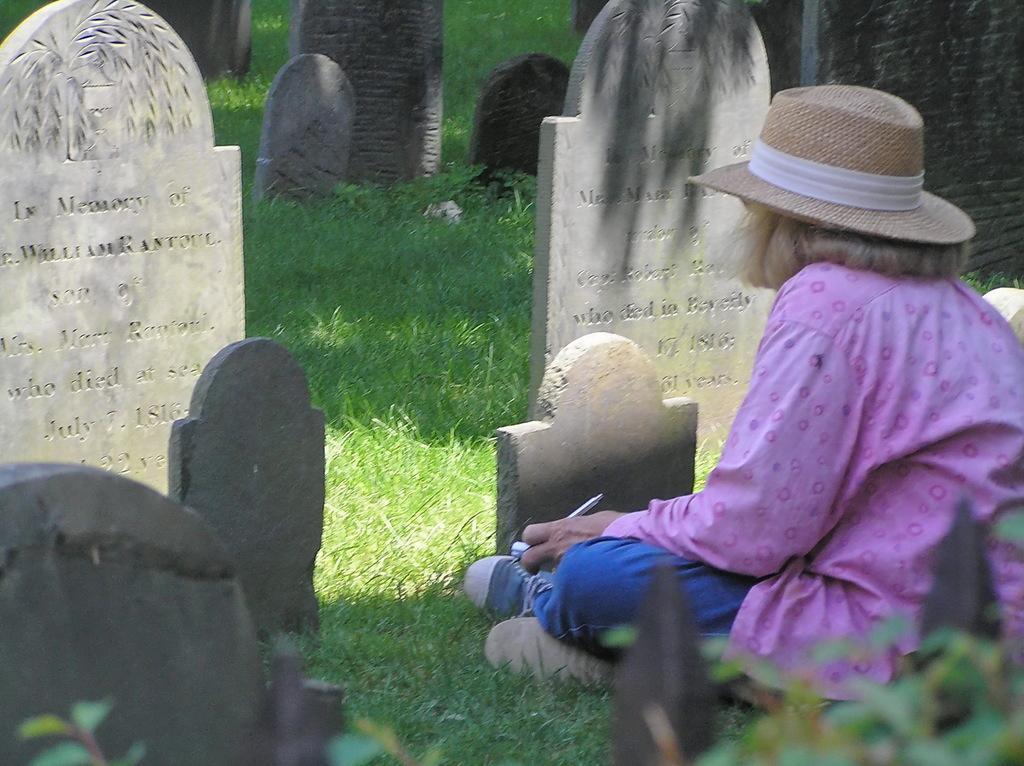Can you describe this image briefly? In this image I can see the cemetery in which I can see some grass and few tombstones which are ash in color. I can see a person wearing pink and blue colored dress is sitting on the ground and holding an object. I can see few trees which are green in color. 